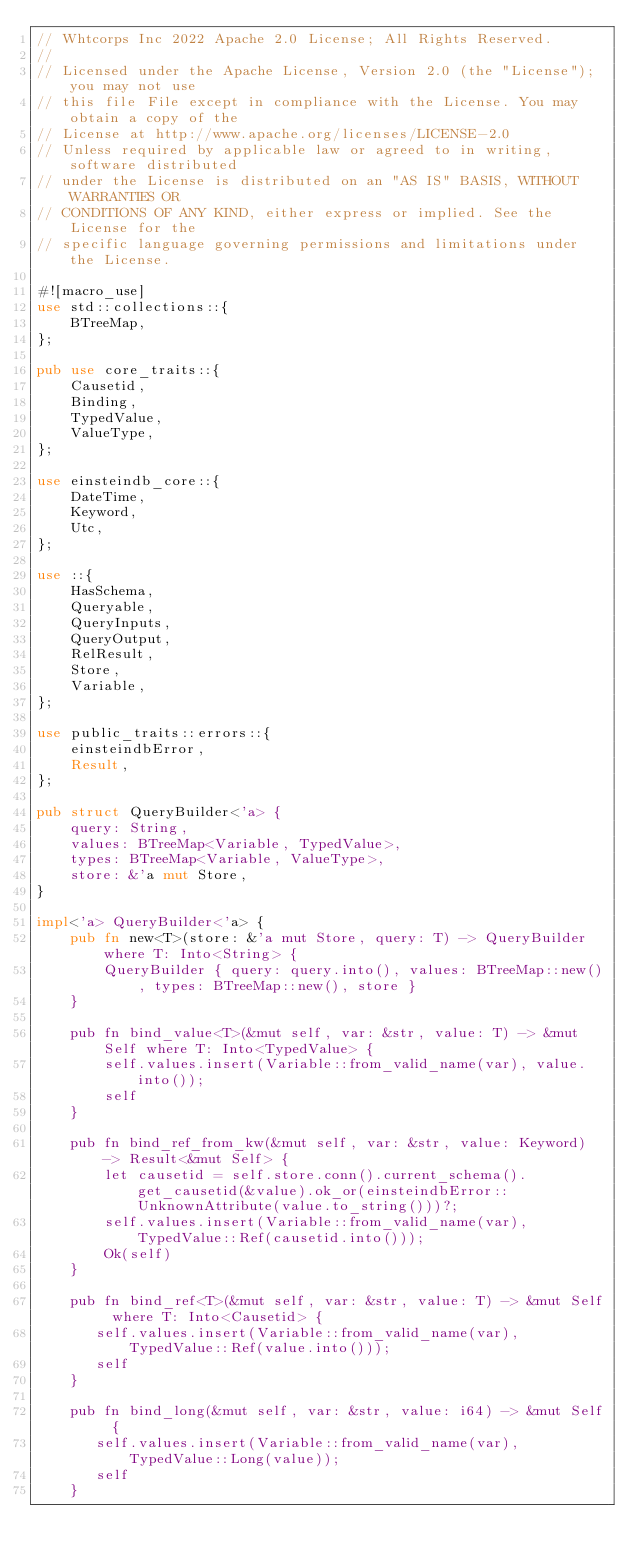<code> <loc_0><loc_0><loc_500><loc_500><_Rust_>// Whtcorps Inc 2022 Apache 2.0 License; All Rights Reserved.
//
// Licensed under the Apache License, Version 2.0 (the "License"); you may not use
// this file File except in compliance with the License. You may obtain a copy of the
// License at http://www.apache.org/licenses/LICENSE-2.0
// Unless required by applicable law or agreed to in writing, software distributed
// under the License is distributed on an "AS IS" BASIS, WITHOUT WARRANTIES OR
// CONDITIONS OF ANY KIND, either express or implied. See the License for the
// specific language governing permissions and limitations under the License.

#![macro_use]
use std::collections::{
    BTreeMap,
};

pub use core_traits::{
    Causetid,
    Binding,
    TypedValue,
    ValueType,
};

use einsteindb_core::{
    DateTime,
    Keyword,
    Utc,
};

use ::{
    HasSchema,
    Queryable,
    QueryInputs,
    QueryOutput,
    RelResult,
    Store,
    Variable,
};

use public_traits::errors::{
    einsteindbError,
    Result,
};

pub struct QueryBuilder<'a> {
    query: String,
    values: BTreeMap<Variable, TypedValue>,
    types: BTreeMap<Variable, ValueType>,
    store: &'a mut Store,
}

impl<'a> QueryBuilder<'a> {
    pub fn new<T>(store: &'a mut Store, query: T) -> QueryBuilder where T: Into<String> {
        QueryBuilder { query: query.into(), values: BTreeMap::new(), types: BTreeMap::new(), store }
    }

    pub fn bind_value<T>(&mut self, var: &str, value: T) -> &mut Self where T: Into<TypedValue> {
        self.values.insert(Variable::from_valid_name(var), value.into());
        self
    }

    pub fn bind_ref_from_kw(&mut self, var: &str, value: Keyword) -> Result<&mut Self> {
        let causetid = self.store.conn().current_schema().get_causetid(&value).ok_or(einsteindbError::UnknownAttribute(value.to_string()))?;
        self.values.insert(Variable::from_valid_name(var), TypedValue::Ref(causetid.into()));
        Ok(self)
    }

    pub fn bind_ref<T>(&mut self, var: &str, value: T) -> &mut Self where T: Into<Causetid> {
       self.values.insert(Variable::from_valid_name(var), TypedValue::Ref(value.into()));
       self
    }

    pub fn bind_long(&mut self, var: &str, value: i64) -> &mut Self {
       self.values.insert(Variable::from_valid_name(var), TypedValue::Long(value));
       self
    }
</code> 